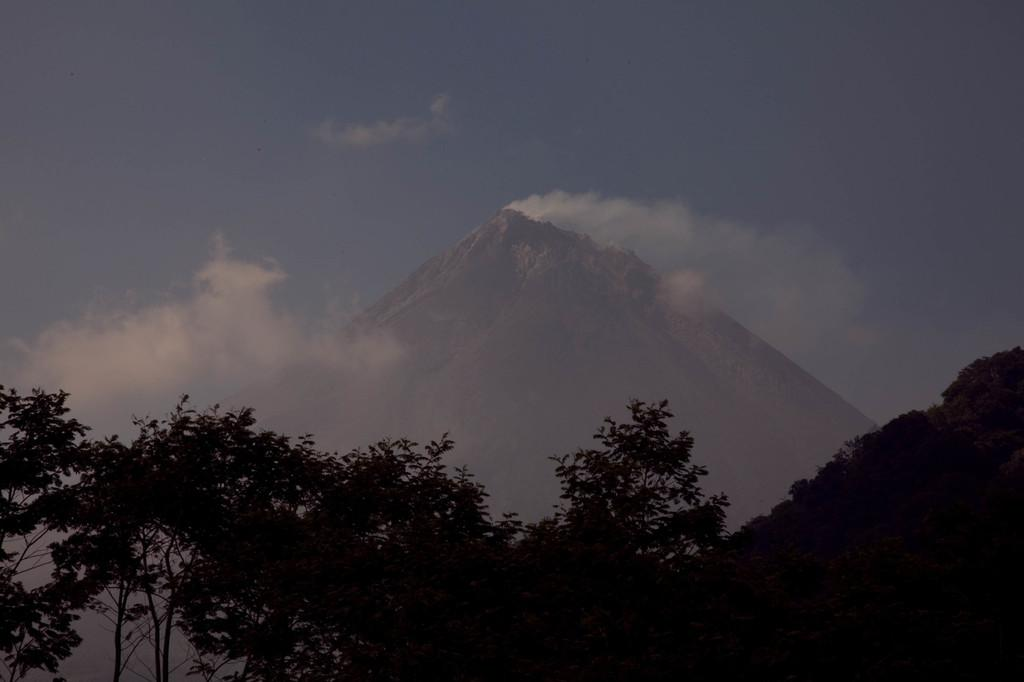What type of vegetation can be seen in the image? There are trees in the image. What geographical feature is present in the image? There is a hill in the image. How would you describe the sky in the background? The sky in the background is blue and cloudy. What type of chain can be seen hanging from the trees in the image? There is no chain present in the image; it features trees, a hill, and a blue and cloudy sky. 